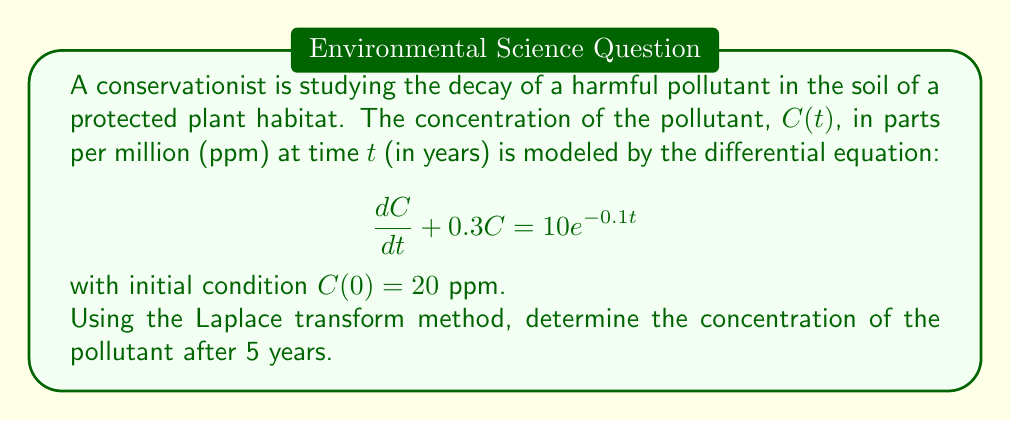Solve this math problem. Let's solve this problem step-by-step using the Laplace transform method:

1) Take the Laplace transform of both sides of the differential equation:
   $$\mathcal{L}\left\{\frac{dC}{dt} + 0.3C\right\} = \mathcal{L}\{10e^{-0.1t}\}$$

2) Using Laplace transform properties:
   $$s\mathcal{L}\{C\} - C(0) + 0.3\mathcal{L}\{C\} = \frac{10}{s+0.1}$$

3) Let $\mathcal{L}\{C\} = F(s)$. Substituting the initial condition $C(0) = 20$:
   $$sF(s) - 20 + 0.3F(s) = \frac{10}{s+0.1}$$

4) Simplify:
   $$(s + 0.3)F(s) = 20 + \frac{10}{s+0.1}$$

5) Solve for $F(s)$:
   $$F(s) = \frac{20}{s + 0.3} + \frac{10}{(s + 0.3)(s + 0.1)}$$

6) Decompose into partial fractions:
   $$F(s) = \frac{20}{s + 0.3} + \frac{A}{s + 0.3} + \frac{B}{s + 0.1}$$
   where $A = \frac{10}{0.3 - 0.1} = 50$ and $B = \frac{-10}{0.3 - 0.1} = -50$

7) Simplify:
   $$F(s) = \frac{70}{s + 0.3} - \frac{50}{s + 0.1}$$

8) Take the inverse Laplace transform:
   $$C(t) = 70e^{-0.3t} - 50e^{-0.1t}$$

9) To find the concentration after 5 years, evaluate $C(5)$:
   $$C(5) = 70e^{-0.3(5)} - 50e^{-0.1(5)}$$
   $$C(5) = 70e^{-1.5} - 50e^{-0.5}$$
   $$C(5) \approx 15.63 - 30.33 = -14.70$$

However, since concentration cannot be negative, we interpret this as the pollutant being completely degraded after 5 years.
Answer: 0 ppm 